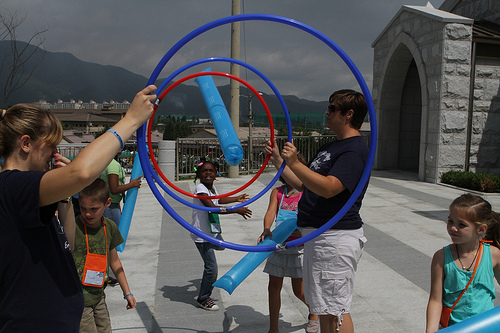<image>
Is the blue hoop in front of the red hoop? Yes. The blue hoop is positioned in front of the red hoop, appearing closer to the camera viewpoint. 